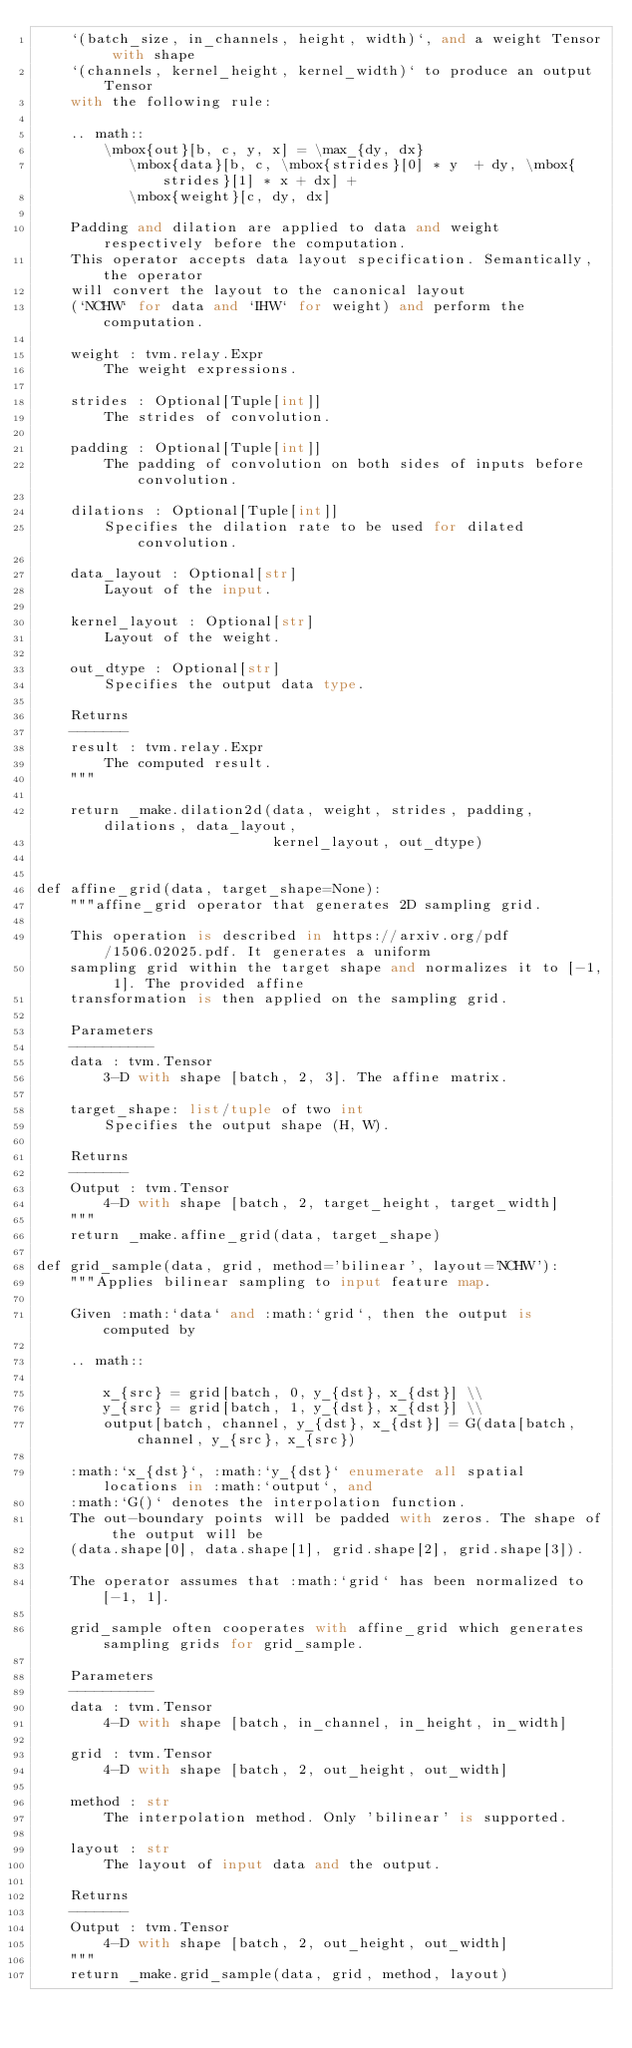Convert code to text. <code><loc_0><loc_0><loc_500><loc_500><_Python_>    `(batch_size, in_channels, height, width)`, and a weight Tensor with shape
    `(channels, kernel_height, kernel_width)` to produce an output Tensor
    with the following rule:

    .. math::
        \mbox{out}[b, c, y, x] = \max_{dy, dx}
           \mbox{data}[b, c, \mbox{strides}[0] * y  + dy, \mbox{strides}[1] * x + dx] +
           \mbox{weight}[c, dy, dx]

    Padding and dilation are applied to data and weight respectively before the computation.
    This operator accepts data layout specification. Semantically, the operator
    will convert the layout to the canonical layout
    (`NCHW` for data and `IHW` for weight) and perform the computation.

    weight : tvm.relay.Expr
        The weight expressions.

    strides : Optional[Tuple[int]]
        The strides of convolution.

    padding : Optional[Tuple[int]]
        The padding of convolution on both sides of inputs before convolution.

    dilations : Optional[Tuple[int]]
        Specifies the dilation rate to be used for dilated convolution.

    data_layout : Optional[str]
        Layout of the input.

    kernel_layout : Optional[str]
        Layout of the weight.

    out_dtype : Optional[str]
        Specifies the output data type.

    Returns
    -------
    result : tvm.relay.Expr
        The computed result.
    """

    return _make.dilation2d(data, weight, strides, padding, dilations, data_layout,
                            kernel_layout, out_dtype)


def affine_grid(data, target_shape=None):
    """affine_grid operator that generates 2D sampling grid.

    This operation is described in https://arxiv.org/pdf/1506.02025.pdf. It generates a uniform
    sampling grid within the target shape and normalizes it to [-1, 1]. The provided affine
    transformation is then applied on the sampling grid.

    Parameters
    ----------
    data : tvm.Tensor
        3-D with shape [batch, 2, 3]. The affine matrix.

    target_shape: list/tuple of two int
        Specifies the output shape (H, W).

    Returns
    -------
    Output : tvm.Tensor
        4-D with shape [batch, 2, target_height, target_width]
    """
    return _make.affine_grid(data, target_shape)

def grid_sample(data, grid, method='bilinear', layout='NCHW'):
    """Applies bilinear sampling to input feature map.

    Given :math:`data` and :math:`grid`, then the output is computed by

    .. math::

        x_{src} = grid[batch, 0, y_{dst}, x_{dst}] \\
        y_{src} = grid[batch, 1, y_{dst}, x_{dst}] \\
        output[batch, channel, y_{dst}, x_{dst}] = G(data[batch, channel, y_{src}, x_{src})

    :math:`x_{dst}`, :math:`y_{dst}` enumerate all spatial locations in :math:`output`, and
    :math:`G()` denotes the interpolation function.
    The out-boundary points will be padded with zeros. The shape of the output will be
    (data.shape[0], data.shape[1], grid.shape[2], grid.shape[3]).

    The operator assumes that :math:`grid` has been normalized to [-1, 1].

    grid_sample often cooperates with affine_grid which generates sampling grids for grid_sample.

    Parameters
    ----------
    data : tvm.Tensor
        4-D with shape [batch, in_channel, in_height, in_width]

    grid : tvm.Tensor
        4-D with shape [batch, 2, out_height, out_width]

    method : str
        The interpolation method. Only 'bilinear' is supported.

    layout : str
        The layout of input data and the output.

    Returns
    -------
    Output : tvm.Tensor
        4-D with shape [batch, 2, out_height, out_width]
    """
    return _make.grid_sample(data, grid, method, layout)
</code> 